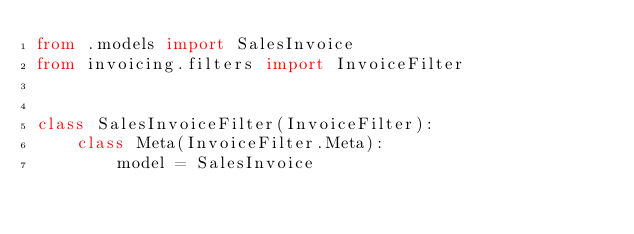<code> <loc_0><loc_0><loc_500><loc_500><_Python_>from .models import SalesInvoice
from invoicing.filters import InvoiceFilter


class SalesInvoiceFilter(InvoiceFilter):
    class Meta(InvoiceFilter.Meta):
        model = SalesInvoice
</code> 